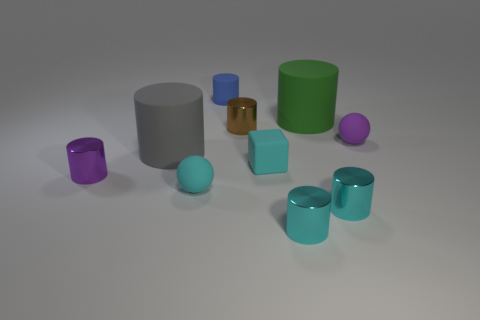What materials do the objects in the image appear to be made of? The objects display a variety of surface textures suggesting different materials: the gray and green cylinders appear to have a matte finish, possibly indicative of ceramic or plastic, while the metallic sheen on the small golden cylinder suggests metal. The remaining objects, given their slight shine, might be made of plastic or coated with a glossier paint. 